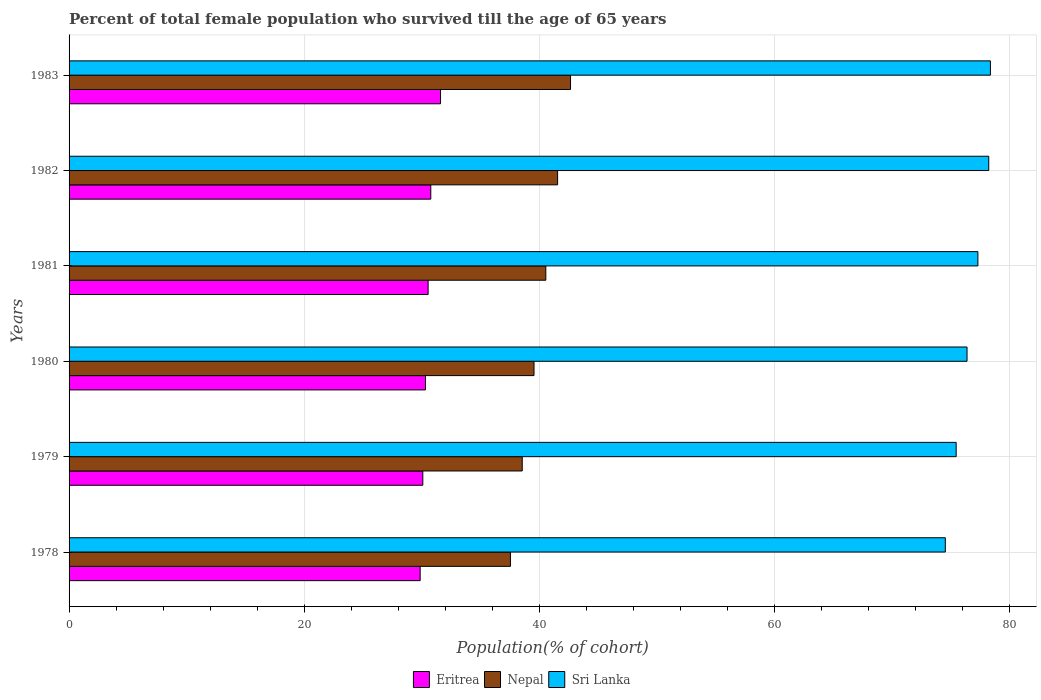How many different coloured bars are there?
Offer a very short reply. 3. How many bars are there on the 3rd tick from the bottom?
Make the answer very short. 3. What is the label of the 5th group of bars from the top?
Your answer should be very brief. 1979. What is the percentage of total female population who survived till the age of 65 years in Nepal in 1983?
Offer a very short reply. 42.66. Across all years, what is the maximum percentage of total female population who survived till the age of 65 years in Nepal?
Your response must be concise. 42.66. Across all years, what is the minimum percentage of total female population who survived till the age of 65 years in Nepal?
Your answer should be compact. 37.55. In which year was the percentage of total female population who survived till the age of 65 years in Nepal maximum?
Your answer should be very brief. 1983. In which year was the percentage of total female population who survived till the age of 65 years in Sri Lanka minimum?
Provide a succinct answer. 1978. What is the total percentage of total female population who survived till the age of 65 years in Eritrea in the graph?
Provide a succinct answer. 183.21. What is the difference between the percentage of total female population who survived till the age of 65 years in Nepal in 1978 and that in 1980?
Offer a very short reply. -2.01. What is the difference between the percentage of total female population who survived till the age of 65 years in Eritrea in 1981 and the percentage of total female population who survived till the age of 65 years in Sri Lanka in 1980?
Your response must be concise. -45.85. What is the average percentage of total female population who survived till the age of 65 years in Sri Lanka per year?
Your answer should be compact. 76.73. In the year 1983, what is the difference between the percentage of total female population who survived till the age of 65 years in Nepal and percentage of total female population who survived till the age of 65 years in Sri Lanka?
Ensure brevity in your answer.  -35.72. What is the ratio of the percentage of total female population who survived till the age of 65 years in Sri Lanka in 1979 to that in 1983?
Keep it short and to the point. 0.96. Is the percentage of total female population who survived till the age of 65 years in Sri Lanka in 1981 less than that in 1983?
Keep it short and to the point. Yes. What is the difference between the highest and the second highest percentage of total female population who survived till the age of 65 years in Nepal?
Provide a succinct answer. 1.1. What is the difference between the highest and the lowest percentage of total female population who survived till the age of 65 years in Nepal?
Your response must be concise. 5.11. What does the 3rd bar from the top in 1982 represents?
Your answer should be very brief. Eritrea. What does the 3rd bar from the bottom in 1983 represents?
Offer a terse response. Sri Lanka. Is it the case that in every year, the sum of the percentage of total female population who survived till the age of 65 years in Sri Lanka and percentage of total female population who survived till the age of 65 years in Nepal is greater than the percentage of total female population who survived till the age of 65 years in Eritrea?
Your answer should be very brief. Yes. How many bars are there?
Provide a succinct answer. 18. Are all the bars in the graph horizontal?
Give a very brief answer. Yes. How many years are there in the graph?
Offer a terse response. 6. What is the difference between two consecutive major ticks on the X-axis?
Offer a very short reply. 20. Does the graph contain any zero values?
Offer a very short reply. No. Does the graph contain grids?
Give a very brief answer. Yes. Where does the legend appear in the graph?
Make the answer very short. Bottom center. How many legend labels are there?
Provide a succinct answer. 3. What is the title of the graph?
Offer a terse response. Percent of total female population who survived till the age of 65 years. What is the label or title of the X-axis?
Your answer should be very brief. Population(% of cohort). What is the Population(% of cohort) of Eritrea in 1978?
Your answer should be compact. 29.87. What is the Population(% of cohort) of Nepal in 1978?
Keep it short and to the point. 37.55. What is the Population(% of cohort) in Sri Lanka in 1978?
Provide a succinct answer. 74.55. What is the Population(% of cohort) in Eritrea in 1979?
Your answer should be compact. 30.1. What is the Population(% of cohort) of Nepal in 1979?
Keep it short and to the point. 38.55. What is the Population(% of cohort) in Sri Lanka in 1979?
Your answer should be compact. 75.47. What is the Population(% of cohort) in Eritrea in 1980?
Provide a succinct answer. 30.32. What is the Population(% of cohort) of Nepal in 1980?
Provide a succinct answer. 39.56. What is the Population(% of cohort) in Sri Lanka in 1980?
Provide a short and direct response. 76.4. What is the Population(% of cohort) in Eritrea in 1981?
Ensure brevity in your answer.  30.55. What is the Population(% of cohort) of Nepal in 1981?
Offer a terse response. 40.56. What is the Population(% of cohort) of Sri Lanka in 1981?
Your response must be concise. 77.32. What is the Population(% of cohort) in Eritrea in 1982?
Keep it short and to the point. 30.77. What is the Population(% of cohort) of Nepal in 1982?
Keep it short and to the point. 41.56. What is the Population(% of cohort) of Sri Lanka in 1982?
Make the answer very short. 78.24. What is the Population(% of cohort) of Eritrea in 1983?
Offer a very short reply. 31.6. What is the Population(% of cohort) of Nepal in 1983?
Give a very brief answer. 42.66. What is the Population(% of cohort) in Sri Lanka in 1983?
Your answer should be compact. 78.39. Across all years, what is the maximum Population(% of cohort) in Eritrea?
Offer a terse response. 31.6. Across all years, what is the maximum Population(% of cohort) in Nepal?
Your answer should be compact. 42.66. Across all years, what is the maximum Population(% of cohort) in Sri Lanka?
Give a very brief answer. 78.39. Across all years, what is the minimum Population(% of cohort) of Eritrea?
Keep it short and to the point. 29.87. Across all years, what is the minimum Population(% of cohort) of Nepal?
Your answer should be very brief. 37.55. Across all years, what is the minimum Population(% of cohort) in Sri Lanka?
Ensure brevity in your answer.  74.55. What is the total Population(% of cohort) of Eritrea in the graph?
Your answer should be very brief. 183.21. What is the total Population(% of cohort) of Nepal in the graph?
Offer a terse response. 240.45. What is the total Population(% of cohort) of Sri Lanka in the graph?
Provide a succinct answer. 460.37. What is the difference between the Population(% of cohort) in Eritrea in 1978 and that in 1979?
Your response must be concise. -0.23. What is the difference between the Population(% of cohort) in Nepal in 1978 and that in 1979?
Offer a very short reply. -1. What is the difference between the Population(% of cohort) of Sri Lanka in 1978 and that in 1979?
Provide a short and direct response. -0.92. What is the difference between the Population(% of cohort) of Eritrea in 1978 and that in 1980?
Offer a very short reply. -0.45. What is the difference between the Population(% of cohort) in Nepal in 1978 and that in 1980?
Provide a short and direct response. -2.01. What is the difference between the Population(% of cohort) in Sri Lanka in 1978 and that in 1980?
Provide a succinct answer. -1.85. What is the difference between the Population(% of cohort) in Eritrea in 1978 and that in 1981?
Ensure brevity in your answer.  -0.68. What is the difference between the Population(% of cohort) of Nepal in 1978 and that in 1981?
Offer a very short reply. -3.01. What is the difference between the Population(% of cohort) of Sri Lanka in 1978 and that in 1981?
Your answer should be compact. -2.77. What is the difference between the Population(% of cohort) in Eritrea in 1978 and that in 1982?
Provide a short and direct response. -0.9. What is the difference between the Population(% of cohort) of Nepal in 1978 and that in 1982?
Make the answer very short. -4.01. What is the difference between the Population(% of cohort) in Sri Lanka in 1978 and that in 1982?
Give a very brief answer. -3.7. What is the difference between the Population(% of cohort) in Eritrea in 1978 and that in 1983?
Your response must be concise. -1.73. What is the difference between the Population(% of cohort) in Nepal in 1978 and that in 1983?
Keep it short and to the point. -5.11. What is the difference between the Population(% of cohort) of Sri Lanka in 1978 and that in 1983?
Offer a very short reply. -3.84. What is the difference between the Population(% of cohort) of Eritrea in 1979 and that in 1980?
Offer a very short reply. -0.23. What is the difference between the Population(% of cohort) in Nepal in 1979 and that in 1980?
Provide a short and direct response. -1. What is the difference between the Population(% of cohort) in Sri Lanka in 1979 and that in 1980?
Your answer should be very brief. -0.92. What is the difference between the Population(% of cohort) in Eritrea in 1979 and that in 1981?
Your answer should be very brief. -0.45. What is the difference between the Population(% of cohort) in Nepal in 1979 and that in 1981?
Offer a very short reply. -2.01. What is the difference between the Population(% of cohort) of Sri Lanka in 1979 and that in 1981?
Provide a succinct answer. -1.85. What is the difference between the Population(% of cohort) in Eritrea in 1979 and that in 1982?
Provide a succinct answer. -0.68. What is the difference between the Population(% of cohort) of Nepal in 1979 and that in 1982?
Offer a terse response. -3.01. What is the difference between the Population(% of cohort) in Sri Lanka in 1979 and that in 1982?
Make the answer very short. -2.77. What is the difference between the Population(% of cohort) of Eritrea in 1979 and that in 1983?
Your answer should be very brief. -1.51. What is the difference between the Population(% of cohort) in Nepal in 1979 and that in 1983?
Make the answer very short. -4.11. What is the difference between the Population(% of cohort) of Sri Lanka in 1979 and that in 1983?
Your answer should be very brief. -2.91. What is the difference between the Population(% of cohort) of Eritrea in 1980 and that in 1981?
Your answer should be compact. -0.23. What is the difference between the Population(% of cohort) in Nepal in 1980 and that in 1981?
Provide a short and direct response. -1. What is the difference between the Population(% of cohort) of Sri Lanka in 1980 and that in 1981?
Your answer should be compact. -0.92. What is the difference between the Population(% of cohort) in Eritrea in 1980 and that in 1982?
Your response must be concise. -0.45. What is the difference between the Population(% of cohort) of Nepal in 1980 and that in 1982?
Keep it short and to the point. -2.01. What is the difference between the Population(% of cohort) in Sri Lanka in 1980 and that in 1982?
Your response must be concise. -1.85. What is the difference between the Population(% of cohort) of Eritrea in 1980 and that in 1983?
Keep it short and to the point. -1.28. What is the difference between the Population(% of cohort) of Nepal in 1980 and that in 1983?
Keep it short and to the point. -3.11. What is the difference between the Population(% of cohort) of Sri Lanka in 1980 and that in 1983?
Provide a short and direct response. -1.99. What is the difference between the Population(% of cohort) in Eritrea in 1981 and that in 1982?
Keep it short and to the point. -0.23. What is the difference between the Population(% of cohort) in Nepal in 1981 and that in 1982?
Provide a short and direct response. -1. What is the difference between the Population(% of cohort) in Sri Lanka in 1981 and that in 1982?
Make the answer very short. -0.92. What is the difference between the Population(% of cohort) of Eritrea in 1981 and that in 1983?
Your answer should be very brief. -1.06. What is the difference between the Population(% of cohort) in Nepal in 1981 and that in 1983?
Ensure brevity in your answer.  -2.1. What is the difference between the Population(% of cohort) of Sri Lanka in 1981 and that in 1983?
Provide a succinct answer. -1.07. What is the difference between the Population(% of cohort) of Eritrea in 1982 and that in 1983?
Ensure brevity in your answer.  -0.83. What is the difference between the Population(% of cohort) in Sri Lanka in 1982 and that in 1983?
Your answer should be compact. -0.14. What is the difference between the Population(% of cohort) in Eritrea in 1978 and the Population(% of cohort) in Nepal in 1979?
Keep it short and to the point. -8.68. What is the difference between the Population(% of cohort) of Eritrea in 1978 and the Population(% of cohort) of Sri Lanka in 1979?
Provide a short and direct response. -45.6. What is the difference between the Population(% of cohort) in Nepal in 1978 and the Population(% of cohort) in Sri Lanka in 1979?
Offer a terse response. -37.92. What is the difference between the Population(% of cohort) in Eritrea in 1978 and the Population(% of cohort) in Nepal in 1980?
Ensure brevity in your answer.  -9.69. What is the difference between the Population(% of cohort) of Eritrea in 1978 and the Population(% of cohort) of Sri Lanka in 1980?
Your answer should be very brief. -46.53. What is the difference between the Population(% of cohort) in Nepal in 1978 and the Population(% of cohort) in Sri Lanka in 1980?
Offer a terse response. -38.85. What is the difference between the Population(% of cohort) in Eritrea in 1978 and the Population(% of cohort) in Nepal in 1981?
Offer a very short reply. -10.69. What is the difference between the Population(% of cohort) in Eritrea in 1978 and the Population(% of cohort) in Sri Lanka in 1981?
Your response must be concise. -47.45. What is the difference between the Population(% of cohort) of Nepal in 1978 and the Population(% of cohort) of Sri Lanka in 1981?
Make the answer very short. -39.77. What is the difference between the Population(% of cohort) of Eritrea in 1978 and the Population(% of cohort) of Nepal in 1982?
Your response must be concise. -11.69. What is the difference between the Population(% of cohort) of Eritrea in 1978 and the Population(% of cohort) of Sri Lanka in 1982?
Give a very brief answer. -48.38. What is the difference between the Population(% of cohort) in Nepal in 1978 and the Population(% of cohort) in Sri Lanka in 1982?
Ensure brevity in your answer.  -40.69. What is the difference between the Population(% of cohort) in Eritrea in 1978 and the Population(% of cohort) in Nepal in 1983?
Make the answer very short. -12.79. What is the difference between the Population(% of cohort) in Eritrea in 1978 and the Population(% of cohort) in Sri Lanka in 1983?
Ensure brevity in your answer.  -48.52. What is the difference between the Population(% of cohort) in Nepal in 1978 and the Population(% of cohort) in Sri Lanka in 1983?
Your response must be concise. -40.84. What is the difference between the Population(% of cohort) of Eritrea in 1979 and the Population(% of cohort) of Nepal in 1980?
Make the answer very short. -9.46. What is the difference between the Population(% of cohort) in Eritrea in 1979 and the Population(% of cohort) in Sri Lanka in 1980?
Ensure brevity in your answer.  -46.3. What is the difference between the Population(% of cohort) in Nepal in 1979 and the Population(% of cohort) in Sri Lanka in 1980?
Your answer should be compact. -37.84. What is the difference between the Population(% of cohort) in Eritrea in 1979 and the Population(% of cohort) in Nepal in 1981?
Give a very brief answer. -10.46. What is the difference between the Population(% of cohort) of Eritrea in 1979 and the Population(% of cohort) of Sri Lanka in 1981?
Your response must be concise. -47.23. What is the difference between the Population(% of cohort) of Nepal in 1979 and the Population(% of cohort) of Sri Lanka in 1981?
Make the answer very short. -38.77. What is the difference between the Population(% of cohort) in Eritrea in 1979 and the Population(% of cohort) in Nepal in 1982?
Your answer should be very brief. -11.47. What is the difference between the Population(% of cohort) in Eritrea in 1979 and the Population(% of cohort) in Sri Lanka in 1982?
Your response must be concise. -48.15. What is the difference between the Population(% of cohort) of Nepal in 1979 and the Population(% of cohort) of Sri Lanka in 1982?
Keep it short and to the point. -39.69. What is the difference between the Population(% of cohort) of Eritrea in 1979 and the Population(% of cohort) of Nepal in 1983?
Offer a terse response. -12.57. What is the difference between the Population(% of cohort) of Eritrea in 1979 and the Population(% of cohort) of Sri Lanka in 1983?
Your answer should be very brief. -48.29. What is the difference between the Population(% of cohort) in Nepal in 1979 and the Population(% of cohort) in Sri Lanka in 1983?
Your answer should be very brief. -39.83. What is the difference between the Population(% of cohort) of Eritrea in 1980 and the Population(% of cohort) of Nepal in 1981?
Provide a short and direct response. -10.24. What is the difference between the Population(% of cohort) of Eritrea in 1980 and the Population(% of cohort) of Sri Lanka in 1981?
Provide a succinct answer. -47. What is the difference between the Population(% of cohort) in Nepal in 1980 and the Population(% of cohort) in Sri Lanka in 1981?
Offer a very short reply. -37.76. What is the difference between the Population(% of cohort) of Eritrea in 1980 and the Population(% of cohort) of Nepal in 1982?
Keep it short and to the point. -11.24. What is the difference between the Population(% of cohort) of Eritrea in 1980 and the Population(% of cohort) of Sri Lanka in 1982?
Provide a short and direct response. -47.92. What is the difference between the Population(% of cohort) in Nepal in 1980 and the Population(% of cohort) in Sri Lanka in 1982?
Your answer should be compact. -38.69. What is the difference between the Population(% of cohort) in Eritrea in 1980 and the Population(% of cohort) in Nepal in 1983?
Ensure brevity in your answer.  -12.34. What is the difference between the Population(% of cohort) in Eritrea in 1980 and the Population(% of cohort) in Sri Lanka in 1983?
Your response must be concise. -48.07. What is the difference between the Population(% of cohort) of Nepal in 1980 and the Population(% of cohort) of Sri Lanka in 1983?
Provide a succinct answer. -38.83. What is the difference between the Population(% of cohort) of Eritrea in 1981 and the Population(% of cohort) of Nepal in 1982?
Offer a very short reply. -11.02. What is the difference between the Population(% of cohort) in Eritrea in 1981 and the Population(% of cohort) in Sri Lanka in 1982?
Provide a short and direct response. -47.7. What is the difference between the Population(% of cohort) of Nepal in 1981 and the Population(% of cohort) of Sri Lanka in 1982?
Your answer should be compact. -37.68. What is the difference between the Population(% of cohort) in Eritrea in 1981 and the Population(% of cohort) in Nepal in 1983?
Give a very brief answer. -12.12. What is the difference between the Population(% of cohort) in Eritrea in 1981 and the Population(% of cohort) in Sri Lanka in 1983?
Your answer should be very brief. -47.84. What is the difference between the Population(% of cohort) in Nepal in 1981 and the Population(% of cohort) in Sri Lanka in 1983?
Your answer should be compact. -37.83. What is the difference between the Population(% of cohort) in Eritrea in 1982 and the Population(% of cohort) in Nepal in 1983?
Ensure brevity in your answer.  -11.89. What is the difference between the Population(% of cohort) of Eritrea in 1982 and the Population(% of cohort) of Sri Lanka in 1983?
Give a very brief answer. -47.61. What is the difference between the Population(% of cohort) of Nepal in 1982 and the Population(% of cohort) of Sri Lanka in 1983?
Make the answer very short. -36.82. What is the average Population(% of cohort) in Eritrea per year?
Keep it short and to the point. 30.54. What is the average Population(% of cohort) in Nepal per year?
Give a very brief answer. 40.07. What is the average Population(% of cohort) in Sri Lanka per year?
Ensure brevity in your answer.  76.73. In the year 1978, what is the difference between the Population(% of cohort) of Eritrea and Population(% of cohort) of Nepal?
Provide a succinct answer. -7.68. In the year 1978, what is the difference between the Population(% of cohort) in Eritrea and Population(% of cohort) in Sri Lanka?
Offer a terse response. -44.68. In the year 1978, what is the difference between the Population(% of cohort) of Nepal and Population(% of cohort) of Sri Lanka?
Your answer should be very brief. -37. In the year 1979, what is the difference between the Population(% of cohort) of Eritrea and Population(% of cohort) of Nepal?
Your answer should be very brief. -8.46. In the year 1979, what is the difference between the Population(% of cohort) in Eritrea and Population(% of cohort) in Sri Lanka?
Your answer should be very brief. -45.38. In the year 1979, what is the difference between the Population(% of cohort) in Nepal and Population(% of cohort) in Sri Lanka?
Give a very brief answer. -36.92. In the year 1980, what is the difference between the Population(% of cohort) of Eritrea and Population(% of cohort) of Nepal?
Ensure brevity in your answer.  -9.24. In the year 1980, what is the difference between the Population(% of cohort) of Eritrea and Population(% of cohort) of Sri Lanka?
Give a very brief answer. -46.08. In the year 1980, what is the difference between the Population(% of cohort) of Nepal and Population(% of cohort) of Sri Lanka?
Your response must be concise. -36.84. In the year 1981, what is the difference between the Population(% of cohort) of Eritrea and Population(% of cohort) of Nepal?
Offer a very short reply. -10.01. In the year 1981, what is the difference between the Population(% of cohort) of Eritrea and Population(% of cohort) of Sri Lanka?
Your answer should be very brief. -46.77. In the year 1981, what is the difference between the Population(% of cohort) in Nepal and Population(% of cohort) in Sri Lanka?
Your answer should be compact. -36.76. In the year 1982, what is the difference between the Population(% of cohort) in Eritrea and Population(% of cohort) in Nepal?
Your answer should be compact. -10.79. In the year 1982, what is the difference between the Population(% of cohort) in Eritrea and Population(% of cohort) in Sri Lanka?
Your answer should be compact. -47.47. In the year 1982, what is the difference between the Population(% of cohort) of Nepal and Population(% of cohort) of Sri Lanka?
Offer a terse response. -36.68. In the year 1983, what is the difference between the Population(% of cohort) in Eritrea and Population(% of cohort) in Nepal?
Offer a terse response. -11.06. In the year 1983, what is the difference between the Population(% of cohort) of Eritrea and Population(% of cohort) of Sri Lanka?
Offer a terse response. -46.78. In the year 1983, what is the difference between the Population(% of cohort) in Nepal and Population(% of cohort) in Sri Lanka?
Offer a terse response. -35.72. What is the ratio of the Population(% of cohort) of Eritrea in 1978 to that in 1980?
Provide a short and direct response. 0.99. What is the ratio of the Population(% of cohort) of Nepal in 1978 to that in 1980?
Provide a short and direct response. 0.95. What is the ratio of the Population(% of cohort) in Sri Lanka in 1978 to that in 1980?
Offer a terse response. 0.98. What is the ratio of the Population(% of cohort) in Eritrea in 1978 to that in 1981?
Give a very brief answer. 0.98. What is the ratio of the Population(% of cohort) in Nepal in 1978 to that in 1981?
Your response must be concise. 0.93. What is the ratio of the Population(% of cohort) of Sri Lanka in 1978 to that in 1981?
Keep it short and to the point. 0.96. What is the ratio of the Population(% of cohort) of Eritrea in 1978 to that in 1982?
Keep it short and to the point. 0.97. What is the ratio of the Population(% of cohort) in Nepal in 1978 to that in 1982?
Your answer should be very brief. 0.9. What is the ratio of the Population(% of cohort) in Sri Lanka in 1978 to that in 1982?
Provide a short and direct response. 0.95. What is the ratio of the Population(% of cohort) of Eritrea in 1978 to that in 1983?
Your answer should be very brief. 0.95. What is the ratio of the Population(% of cohort) in Nepal in 1978 to that in 1983?
Your answer should be very brief. 0.88. What is the ratio of the Population(% of cohort) of Sri Lanka in 1978 to that in 1983?
Your answer should be compact. 0.95. What is the ratio of the Population(% of cohort) of Eritrea in 1979 to that in 1980?
Make the answer very short. 0.99. What is the ratio of the Population(% of cohort) of Nepal in 1979 to that in 1980?
Your answer should be compact. 0.97. What is the ratio of the Population(% of cohort) of Sri Lanka in 1979 to that in 1980?
Provide a succinct answer. 0.99. What is the ratio of the Population(% of cohort) in Eritrea in 1979 to that in 1981?
Your answer should be very brief. 0.99. What is the ratio of the Population(% of cohort) in Nepal in 1979 to that in 1981?
Provide a short and direct response. 0.95. What is the ratio of the Population(% of cohort) of Sri Lanka in 1979 to that in 1981?
Offer a very short reply. 0.98. What is the ratio of the Population(% of cohort) of Nepal in 1979 to that in 1982?
Your answer should be compact. 0.93. What is the ratio of the Population(% of cohort) of Sri Lanka in 1979 to that in 1982?
Provide a short and direct response. 0.96. What is the ratio of the Population(% of cohort) of Eritrea in 1979 to that in 1983?
Your answer should be compact. 0.95. What is the ratio of the Population(% of cohort) of Nepal in 1979 to that in 1983?
Provide a short and direct response. 0.9. What is the ratio of the Population(% of cohort) in Sri Lanka in 1979 to that in 1983?
Provide a succinct answer. 0.96. What is the ratio of the Population(% of cohort) of Nepal in 1980 to that in 1981?
Offer a terse response. 0.98. What is the ratio of the Population(% of cohort) of Sri Lanka in 1980 to that in 1981?
Keep it short and to the point. 0.99. What is the ratio of the Population(% of cohort) in Eritrea in 1980 to that in 1982?
Your answer should be very brief. 0.99. What is the ratio of the Population(% of cohort) in Nepal in 1980 to that in 1982?
Your answer should be compact. 0.95. What is the ratio of the Population(% of cohort) of Sri Lanka in 1980 to that in 1982?
Your answer should be compact. 0.98. What is the ratio of the Population(% of cohort) of Eritrea in 1980 to that in 1983?
Make the answer very short. 0.96. What is the ratio of the Population(% of cohort) in Nepal in 1980 to that in 1983?
Offer a very short reply. 0.93. What is the ratio of the Population(% of cohort) of Sri Lanka in 1980 to that in 1983?
Ensure brevity in your answer.  0.97. What is the ratio of the Population(% of cohort) of Eritrea in 1981 to that in 1982?
Make the answer very short. 0.99. What is the ratio of the Population(% of cohort) in Nepal in 1981 to that in 1982?
Offer a terse response. 0.98. What is the ratio of the Population(% of cohort) in Sri Lanka in 1981 to that in 1982?
Keep it short and to the point. 0.99. What is the ratio of the Population(% of cohort) in Eritrea in 1981 to that in 1983?
Your response must be concise. 0.97. What is the ratio of the Population(% of cohort) in Nepal in 1981 to that in 1983?
Provide a short and direct response. 0.95. What is the ratio of the Population(% of cohort) of Sri Lanka in 1981 to that in 1983?
Make the answer very short. 0.99. What is the ratio of the Population(% of cohort) in Eritrea in 1982 to that in 1983?
Offer a very short reply. 0.97. What is the ratio of the Population(% of cohort) in Nepal in 1982 to that in 1983?
Ensure brevity in your answer.  0.97. What is the difference between the highest and the second highest Population(% of cohort) of Eritrea?
Provide a succinct answer. 0.83. What is the difference between the highest and the second highest Population(% of cohort) in Nepal?
Keep it short and to the point. 1.1. What is the difference between the highest and the second highest Population(% of cohort) of Sri Lanka?
Provide a succinct answer. 0.14. What is the difference between the highest and the lowest Population(% of cohort) in Eritrea?
Your answer should be compact. 1.73. What is the difference between the highest and the lowest Population(% of cohort) of Nepal?
Ensure brevity in your answer.  5.11. What is the difference between the highest and the lowest Population(% of cohort) in Sri Lanka?
Provide a succinct answer. 3.84. 